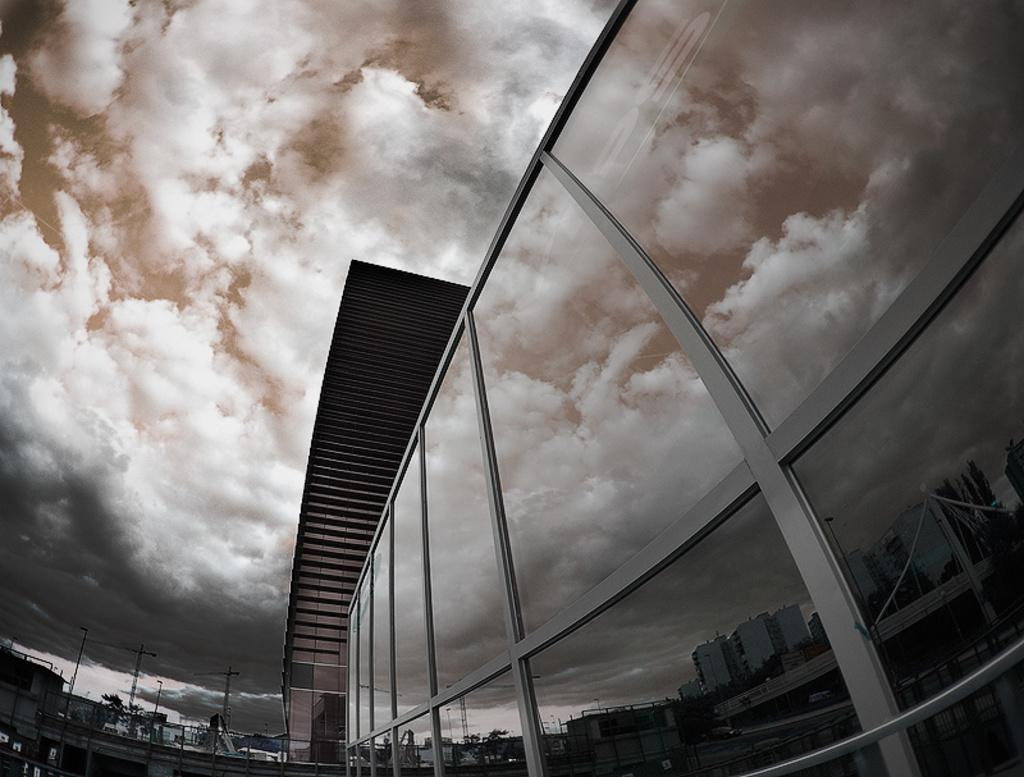What type of structures can be seen in the image? There are buildings in the image. What else is present in the image besides the buildings? There are poles in the image. What can be seen in the background of the image? The sky with clouds is visible in the background of the image. Can you describe the reflection on the glasses in the image? There is a reflection on the glasses in the image. What type of mint is growing on the buildings in the image? There is no mint growing on the buildings in the image; it is not mentioned in the provided facts. 